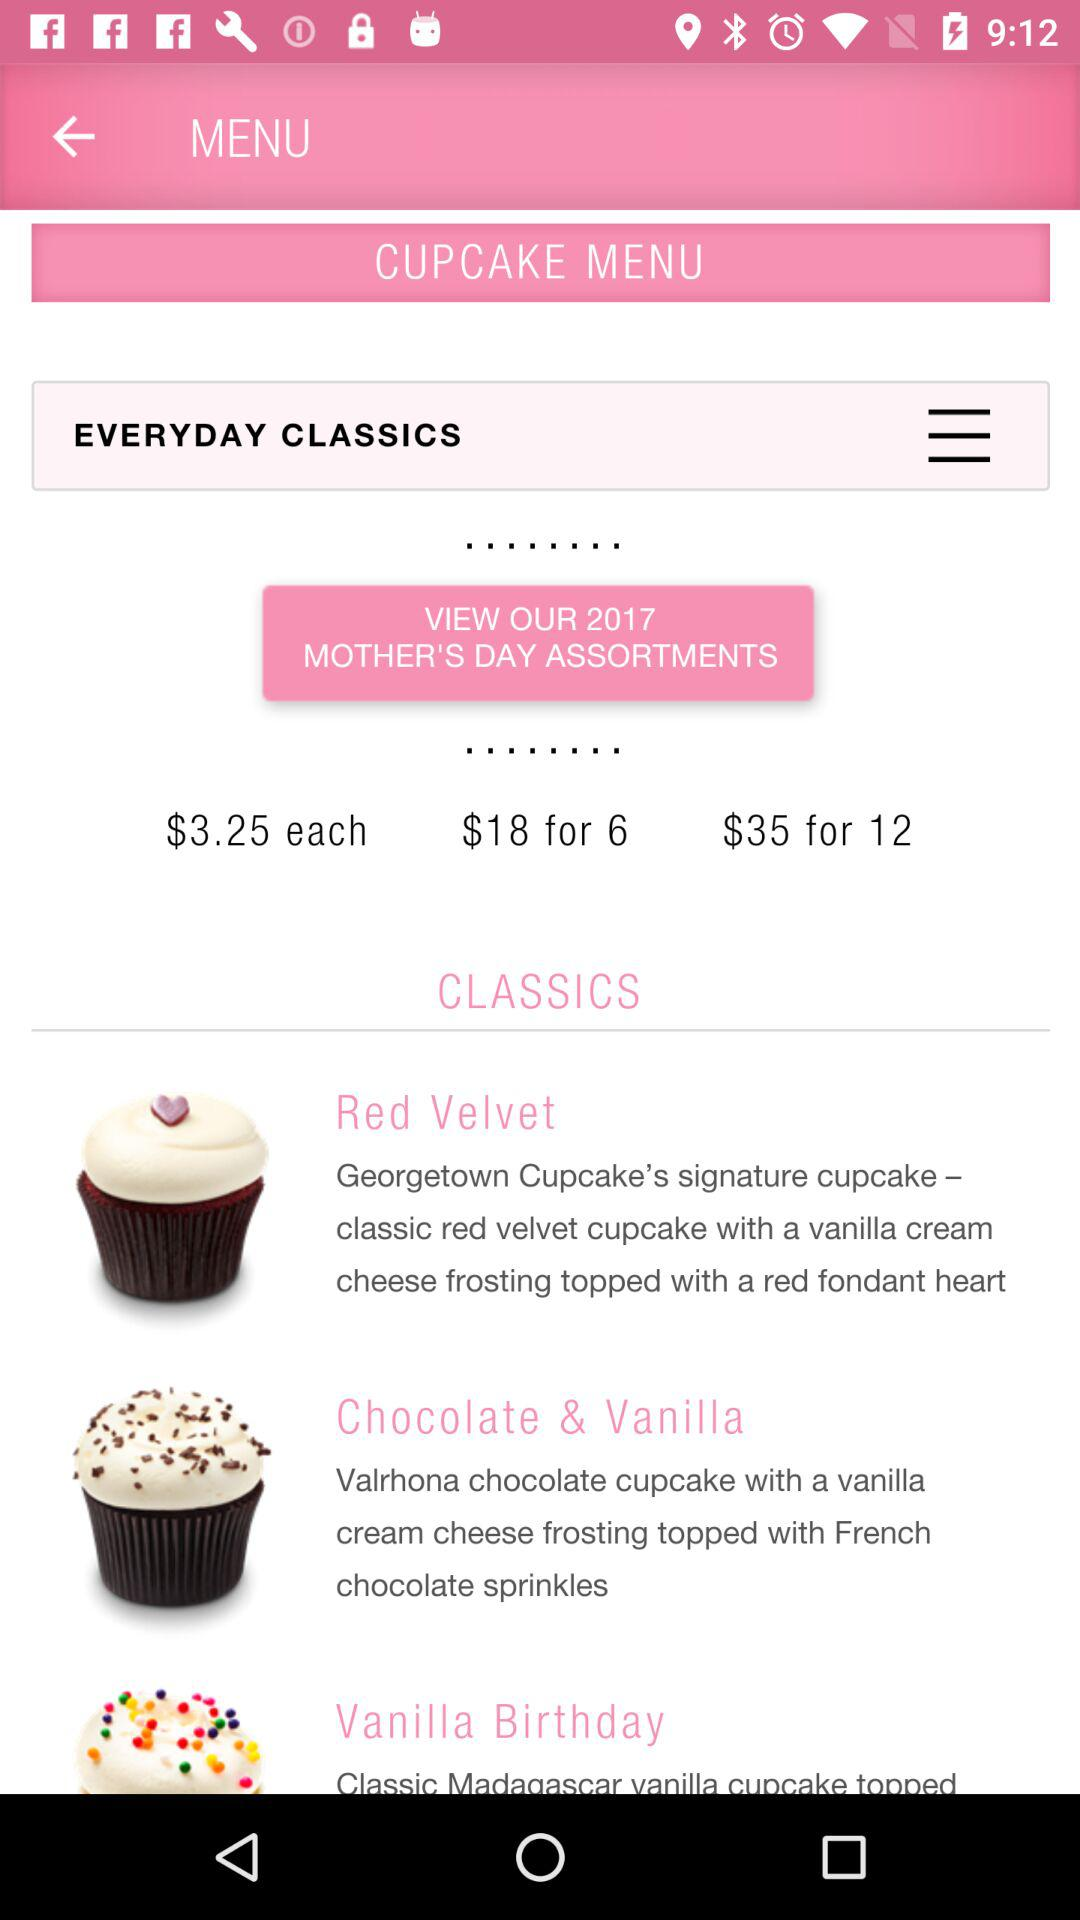What is the price of one cupcake? The price of one cupcake is $3.25. 